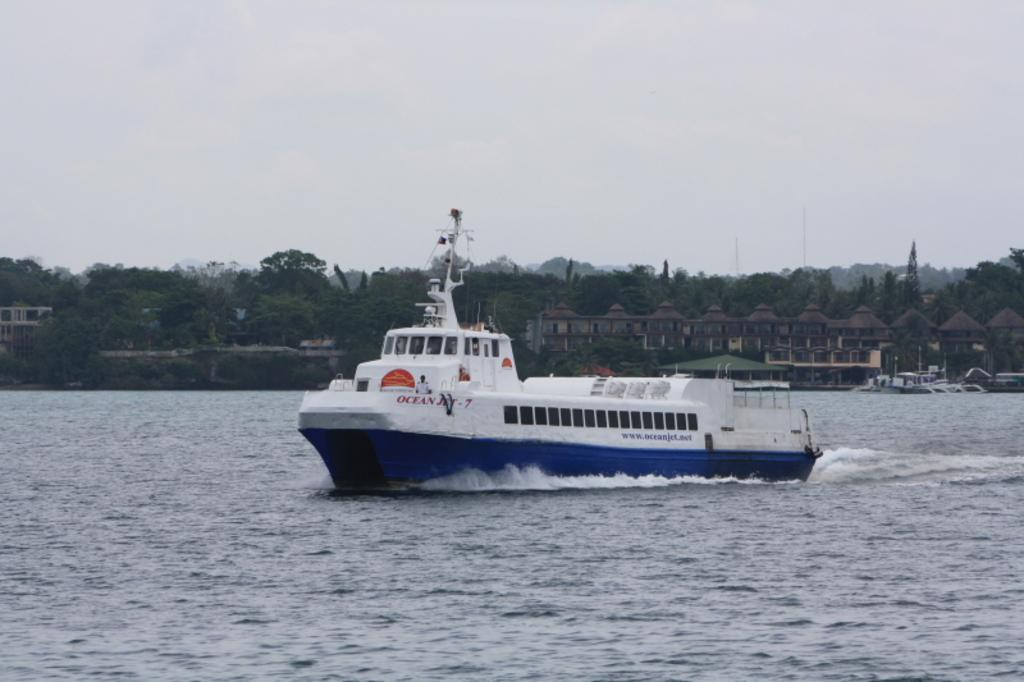What is in the water in the image? There is a boat in the water in the image. What structures can be seen in the image? There are buildings visible in the image. What type of vegetation is present in the image? There are trees in the image. What are the poles used for in the image? The purpose of the poles is not specified, but they could be used for mooring the boat or for other purposes. What is visible in the background of the image? The sky is visible in the image. How does the boat slip on the ice in the image? There is no ice present in the image, and the boat is in the water, not on ice. 